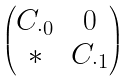<formula> <loc_0><loc_0><loc_500><loc_500>\left ( \begin{matrix} C _ { \cdot 0 } & 0 \\ * & C _ { \cdot 1 } \end{matrix} \right )</formula> 